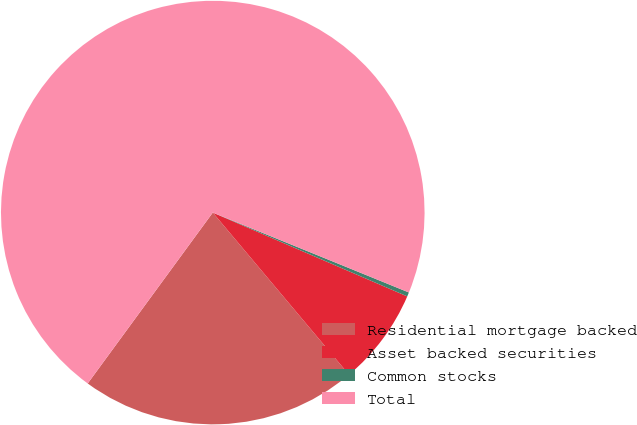<chart> <loc_0><loc_0><loc_500><loc_500><pie_chart><fcel>Residential mortgage backed<fcel>Asset backed securities<fcel>Common stocks<fcel>Total<nl><fcel>21.18%<fcel>7.4%<fcel>0.32%<fcel>71.11%<nl></chart> 